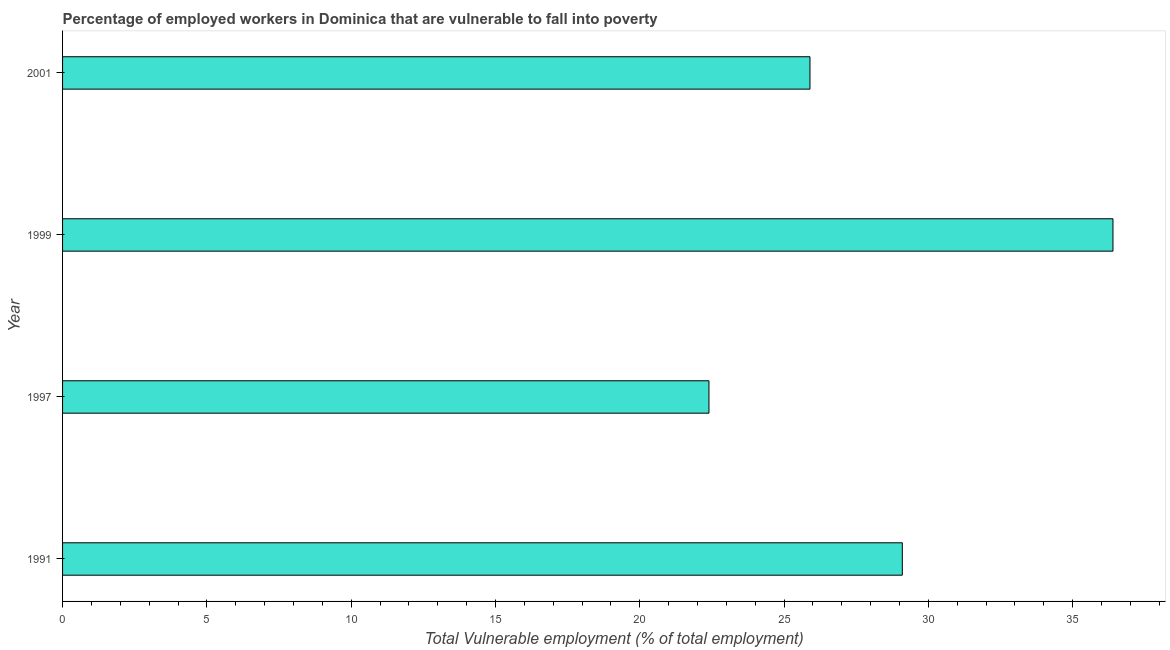What is the title of the graph?
Offer a very short reply. Percentage of employed workers in Dominica that are vulnerable to fall into poverty. What is the label or title of the X-axis?
Give a very brief answer. Total Vulnerable employment (% of total employment). What is the label or title of the Y-axis?
Keep it short and to the point. Year. What is the total vulnerable employment in 1997?
Offer a very short reply. 22.4. Across all years, what is the maximum total vulnerable employment?
Make the answer very short. 36.4. Across all years, what is the minimum total vulnerable employment?
Your answer should be compact. 22.4. In which year was the total vulnerable employment minimum?
Ensure brevity in your answer.  1997. What is the sum of the total vulnerable employment?
Provide a succinct answer. 113.8. What is the difference between the total vulnerable employment in 1999 and 2001?
Offer a very short reply. 10.5. What is the average total vulnerable employment per year?
Ensure brevity in your answer.  28.45. What is the ratio of the total vulnerable employment in 1997 to that in 2001?
Offer a terse response. 0.86. Is the total vulnerable employment in 1999 less than that in 2001?
Make the answer very short. No. Is the difference between the total vulnerable employment in 1991 and 1999 greater than the difference between any two years?
Your answer should be very brief. No. What is the difference between the highest and the second highest total vulnerable employment?
Your answer should be very brief. 7.3. What is the difference between the highest and the lowest total vulnerable employment?
Make the answer very short. 14. How many bars are there?
Your response must be concise. 4. Are all the bars in the graph horizontal?
Your response must be concise. Yes. How many years are there in the graph?
Give a very brief answer. 4. What is the difference between two consecutive major ticks on the X-axis?
Keep it short and to the point. 5. Are the values on the major ticks of X-axis written in scientific E-notation?
Offer a terse response. No. What is the Total Vulnerable employment (% of total employment) of 1991?
Your answer should be very brief. 29.1. What is the Total Vulnerable employment (% of total employment) in 1997?
Your answer should be compact. 22.4. What is the Total Vulnerable employment (% of total employment) of 1999?
Your answer should be very brief. 36.4. What is the Total Vulnerable employment (% of total employment) of 2001?
Make the answer very short. 25.9. What is the difference between the Total Vulnerable employment (% of total employment) in 1991 and 1997?
Ensure brevity in your answer.  6.7. What is the difference between the Total Vulnerable employment (% of total employment) in 1991 and 1999?
Your answer should be compact. -7.3. What is the difference between the Total Vulnerable employment (% of total employment) in 1997 and 2001?
Make the answer very short. -3.5. What is the difference between the Total Vulnerable employment (% of total employment) in 1999 and 2001?
Your response must be concise. 10.5. What is the ratio of the Total Vulnerable employment (% of total employment) in 1991 to that in 1997?
Provide a short and direct response. 1.3. What is the ratio of the Total Vulnerable employment (% of total employment) in 1991 to that in 1999?
Provide a succinct answer. 0.8. What is the ratio of the Total Vulnerable employment (% of total employment) in 1991 to that in 2001?
Keep it short and to the point. 1.12. What is the ratio of the Total Vulnerable employment (% of total employment) in 1997 to that in 1999?
Give a very brief answer. 0.61. What is the ratio of the Total Vulnerable employment (% of total employment) in 1997 to that in 2001?
Keep it short and to the point. 0.86. What is the ratio of the Total Vulnerable employment (% of total employment) in 1999 to that in 2001?
Provide a succinct answer. 1.41. 